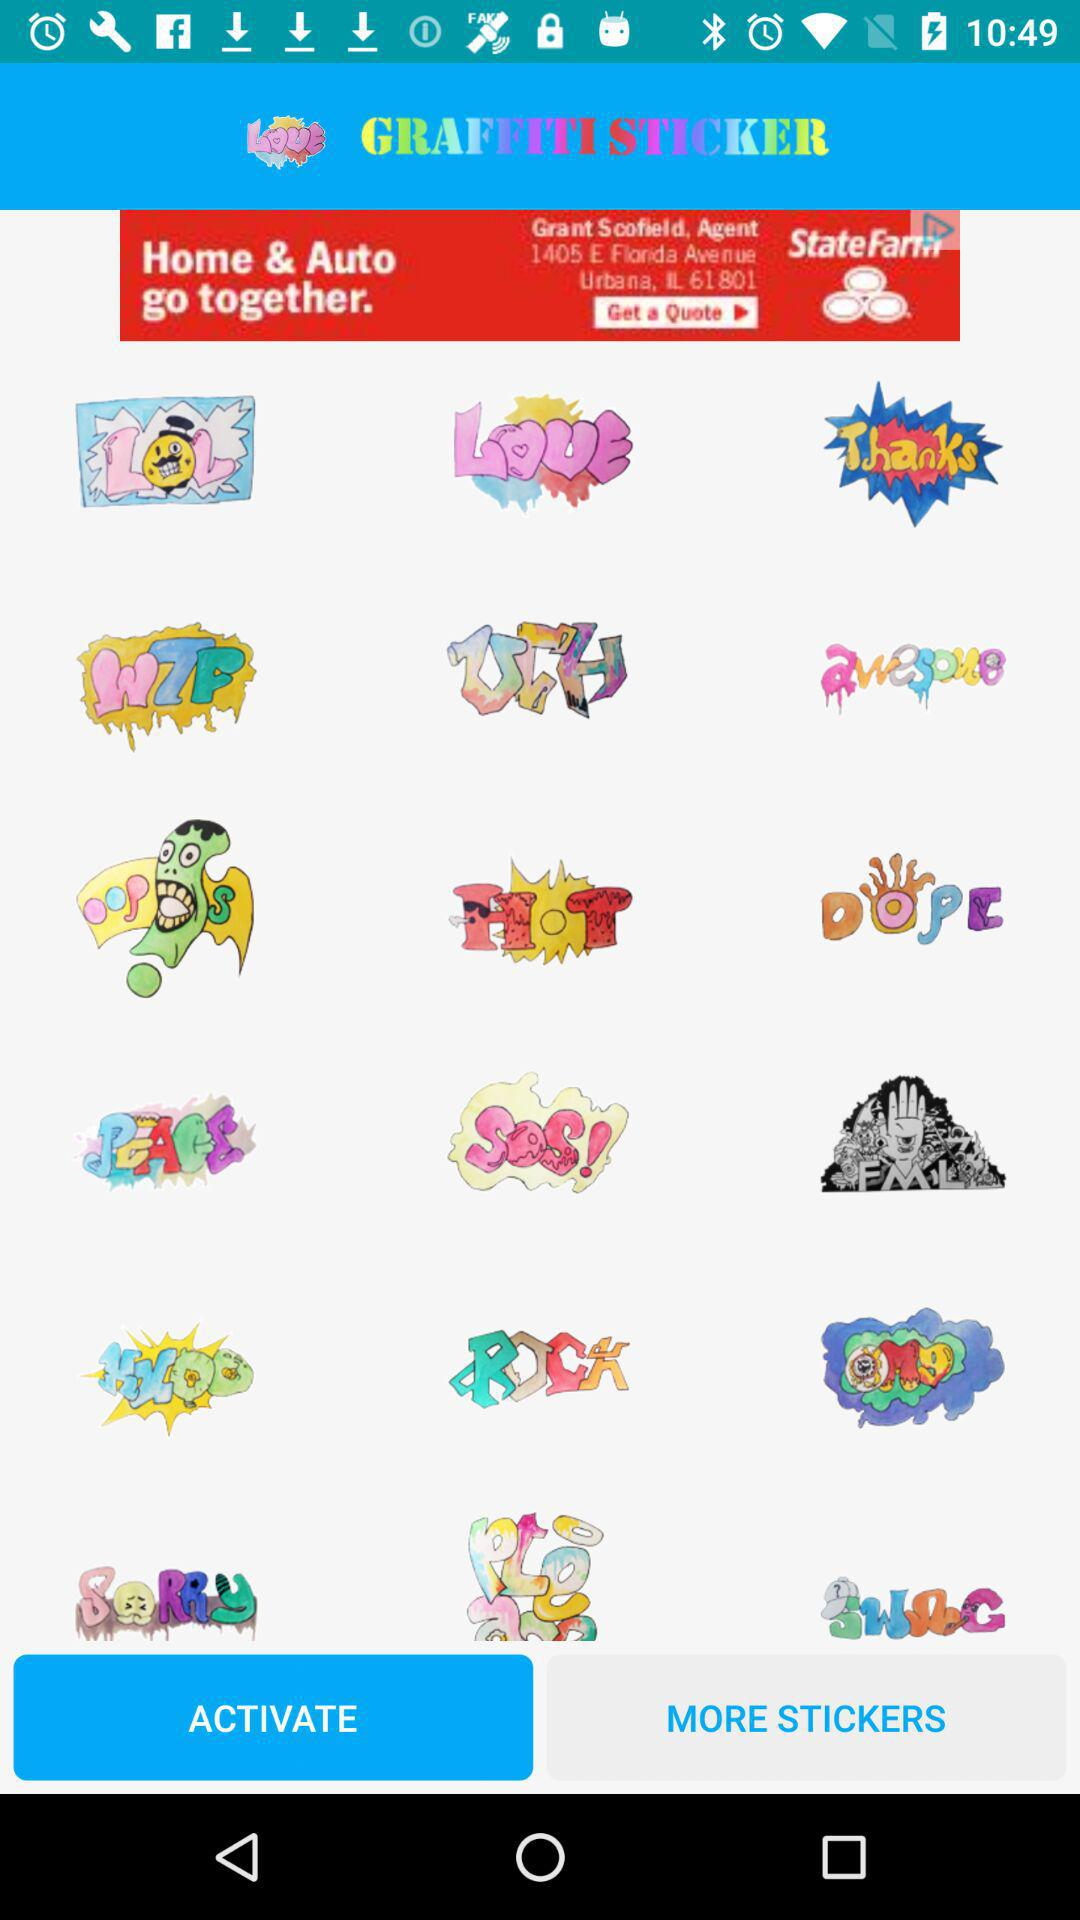What is the app name? The app name is "GRAFFITI STICKER". 